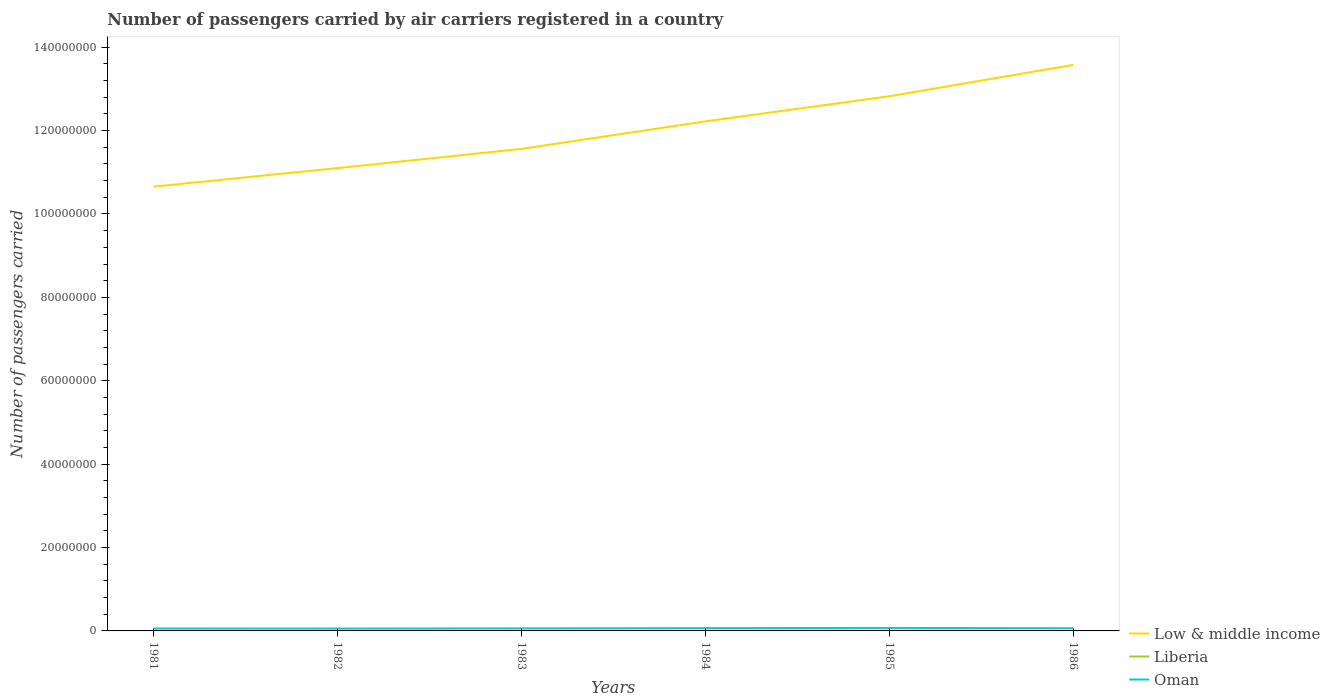Across all years, what is the maximum number of passengers carried by air carriers in Oman?
Provide a succinct answer. 5.70e+05. What is the total number of passengers carried by air carriers in Low & middle income in the graph?
Provide a succinct answer. -2.48e+07. What is the difference between the highest and the second highest number of passengers carried by air carriers in Low & middle income?
Provide a short and direct response. 2.92e+07. What is the difference between the highest and the lowest number of passengers carried by air carriers in Oman?
Your answer should be very brief. 3. How many lines are there?
Provide a succinct answer. 3. How many years are there in the graph?
Your answer should be compact. 6. Are the values on the major ticks of Y-axis written in scientific E-notation?
Provide a short and direct response. No. Where does the legend appear in the graph?
Give a very brief answer. Bottom right. How many legend labels are there?
Give a very brief answer. 3. How are the legend labels stacked?
Give a very brief answer. Vertical. What is the title of the graph?
Give a very brief answer. Number of passengers carried by air carriers registered in a country. Does "Uganda" appear as one of the legend labels in the graph?
Ensure brevity in your answer.  No. What is the label or title of the X-axis?
Your response must be concise. Years. What is the label or title of the Y-axis?
Your answer should be compact. Number of passengers carried. What is the Number of passengers carried of Low & middle income in 1981?
Give a very brief answer. 1.07e+08. What is the Number of passengers carried of Liberia in 1981?
Your answer should be very brief. 3.04e+04. What is the Number of passengers carried of Oman in 1981?
Your answer should be compact. 5.78e+05. What is the Number of passengers carried of Low & middle income in 1982?
Give a very brief answer. 1.11e+08. What is the Number of passengers carried in Liberia in 1982?
Provide a succinct answer. 4.09e+04. What is the Number of passengers carried in Oman in 1982?
Offer a terse response. 5.70e+05. What is the Number of passengers carried in Low & middle income in 1983?
Make the answer very short. 1.16e+08. What is the Number of passengers carried of Liberia in 1983?
Your answer should be very brief. 4.40e+04. What is the Number of passengers carried in Oman in 1983?
Make the answer very short. 6.02e+05. What is the Number of passengers carried in Low & middle income in 1984?
Your response must be concise. 1.22e+08. What is the Number of passengers carried in Oman in 1984?
Provide a short and direct response. 6.74e+05. What is the Number of passengers carried of Low & middle income in 1985?
Ensure brevity in your answer.  1.28e+08. What is the Number of passengers carried in Liberia in 1985?
Ensure brevity in your answer.  4.20e+04. What is the Number of passengers carried in Oman in 1985?
Ensure brevity in your answer.  7.18e+05. What is the Number of passengers carried of Low & middle income in 1986?
Your response must be concise. 1.36e+08. What is the Number of passengers carried in Liberia in 1986?
Your response must be concise. 4.20e+04. What is the Number of passengers carried of Oman in 1986?
Your answer should be very brief. 6.47e+05. Across all years, what is the maximum Number of passengers carried of Low & middle income?
Keep it short and to the point. 1.36e+08. Across all years, what is the maximum Number of passengers carried in Oman?
Offer a very short reply. 7.18e+05. Across all years, what is the minimum Number of passengers carried of Low & middle income?
Ensure brevity in your answer.  1.07e+08. Across all years, what is the minimum Number of passengers carried in Liberia?
Provide a succinct answer. 3.04e+04. Across all years, what is the minimum Number of passengers carried in Oman?
Provide a succinct answer. 5.70e+05. What is the total Number of passengers carried of Low & middle income in the graph?
Give a very brief answer. 7.19e+08. What is the total Number of passengers carried of Liberia in the graph?
Offer a very short reply. 2.49e+05. What is the total Number of passengers carried in Oman in the graph?
Ensure brevity in your answer.  3.79e+06. What is the difference between the Number of passengers carried in Low & middle income in 1981 and that in 1982?
Keep it short and to the point. -4.45e+06. What is the difference between the Number of passengers carried of Liberia in 1981 and that in 1982?
Give a very brief answer. -1.05e+04. What is the difference between the Number of passengers carried of Oman in 1981 and that in 1982?
Give a very brief answer. 8000. What is the difference between the Number of passengers carried in Low & middle income in 1981 and that in 1983?
Keep it short and to the point. -9.05e+06. What is the difference between the Number of passengers carried of Liberia in 1981 and that in 1983?
Your response must be concise. -1.36e+04. What is the difference between the Number of passengers carried in Oman in 1981 and that in 1983?
Your answer should be compact. -2.40e+04. What is the difference between the Number of passengers carried in Low & middle income in 1981 and that in 1984?
Your answer should be very brief. -1.57e+07. What is the difference between the Number of passengers carried in Liberia in 1981 and that in 1984?
Give a very brief answer. -1.96e+04. What is the difference between the Number of passengers carried of Oman in 1981 and that in 1984?
Make the answer very short. -9.64e+04. What is the difference between the Number of passengers carried of Low & middle income in 1981 and that in 1985?
Offer a terse response. -2.17e+07. What is the difference between the Number of passengers carried in Liberia in 1981 and that in 1985?
Give a very brief answer. -1.16e+04. What is the difference between the Number of passengers carried of Oman in 1981 and that in 1985?
Offer a very short reply. -1.40e+05. What is the difference between the Number of passengers carried of Low & middle income in 1981 and that in 1986?
Your answer should be compact. -2.92e+07. What is the difference between the Number of passengers carried of Liberia in 1981 and that in 1986?
Your answer should be very brief. -1.16e+04. What is the difference between the Number of passengers carried in Oman in 1981 and that in 1986?
Offer a very short reply. -6.96e+04. What is the difference between the Number of passengers carried in Low & middle income in 1982 and that in 1983?
Your response must be concise. -4.61e+06. What is the difference between the Number of passengers carried of Liberia in 1982 and that in 1983?
Your answer should be compact. -3100. What is the difference between the Number of passengers carried in Oman in 1982 and that in 1983?
Give a very brief answer. -3.20e+04. What is the difference between the Number of passengers carried in Low & middle income in 1982 and that in 1984?
Give a very brief answer. -1.12e+07. What is the difference between the Number of passengers carried of Liberia in 1982 and that in 1984?
Your response must be concise. -9100. What is the difference between the Number of passengers carried in Oman in 1982 and that in 1984?
Make the answer very short. -1.04e+05. What is the difference between the Number of passengers carried in Low & middle income in 1982 and that in 1985?
Offer a very short reply. -1.72e+07. What is the difference between the Number of passengers carried in Liberia in 1982 and that in 1985?
Provide a short and direct response. -1100. What is the difference between the Number of passengers carried of Oman in 1982 and that in 1985?
Provide a succinct answer. -1.48e+05. What is the difference between the Number of passengers carried of Low & middle income in 1982 and that in 1986?
Make the answer very short. -2.48e+07. What is the difference between the Number of passengers carried in Liberia in 1982 and that in 1986?
Ensure brevity in your answer.  -1100. What is the difference between the Number of passengers carried in Oman in 1982 and that in 1986?
Provide a short and direct response. -7.76e+04. What is the difference between the Number of passengers carried of Low & middle income in 1983 and that in 1984?
Your answer should be compact. -6.60e+06. What is the difference between the Number of passengers carried of Liberia in 1983 and that in 1984?
Make the answer very short. -6000. What is the difference between the Number of passengers carried of Oman in 1983 and that in 1984?
Provide a succinct answer. -7.24e+04. What is the difference between the Number of passengers carried in Low & middle income in 1983 and that in 1985?
Keep it short and to the point. -1.26e+07. What is the difference between the Number of passengers carried of Liberia in 1983 and that in 1985?
Your answer should be very brief. 2000. What is the difference between the Number of passengers carried in Oman in 1983 and that in 1985?
Your answer should be compact. -1.16e+05. What is the difference between the Number of passengers carried of Low & middle income in 1983 and that in 1986?
Offer a terse response. -2.02e+07. What is the difference between the Number of passengers carried in Liberia in 1983 and that in 1986?
Keep it short and to the point. 2000. What is the difference between the Number of passengers carried of Oman in 1983 and that in 1986?
Ensure brevity in your answer.  -4.56e+04. What is the difference between the Number of passengers carried of Low & middle income in 1984 and that in 1985?
Give a very brief answer. -6.03e+06. What is the difference between the Number of passengers carried of Liberia in 1984 and that in 1985?
Ensure brevity in your answer.  8000. What is the difference between the Number of passengers carried of Oman in 1984 and that in 1985?
Ensure brevity in your answer.  -4.33e+04. What is the difference between the Number of passengers carried in Low & middle income in 1984 and that in 1986?
Keep it short and to the point. -1.35e+07. What is the difference between the Number of passengers carried in Liberia in 1984 and that in 1986?
Your response must be concise. 8000. What is the difference between the Number of passengers carried in Oman in 1984 and that in 1986?
Provide a succinct answer. 2.68e+04. What is the difference between the Number of passengers carried of Low & middle income in 1985 and that in 1986?
Your answer should be very brief. -7.52e+06. What is the difference between the Number of passengers carried in Oman in 1985 and that in 1986?
Offer a terse response. 7.01e+04. What is the difference between the Number of passengers carried in Low & middle income in 1981 and the Number of passengers carried in Liberia in 1982?
Offer a terse response. 1.07e+08. What is the difference between the Number of passengers carried of Low & middle income in 1981 and the Number of passengers carried of Oman in 1982?
Provide a short and direct response. 1.06e+08. What is the difference between the Number of passengers carried in Liberia in 1981 and the Number of passengers carried in Oman in 1982?
Your answer should be compact. -5.39e+05. What is the difference between the Number of passengers carried of Low & middle income in 1981 and the Number of passengers carried of Liberia in 1983?
Give a very brief answer. 1.07e+08. What is the difference between the Number of passengers carried of Low & middle income in 1981 and the Number of passengers carried of Oman in 1983?
Keep it short and to the point. 1.06e+08. What is the difference between the Number of passengers carried in Liberia in 1981 and the Number of passengers carried in Oman in 1983?
Your answer should be compact. -5.71e+05. What is the difference between the Number of passengers carried in Low & middle income in 1981 and the Number of passengers carried in Liberia in 1984?
Offer a terse response. 1.07e+08. What is the difference between the Number of passengers carried in Low & middle income in 1981 and the Number of passengers carried in Oman in 1984?
Offer a very short reply. 1.06e+08. What is the difference between the Number of passengers carried in Liberia in 1981 and the Number of passengers carried in Oman in 1984?
Offer a terse response. -6.44e+05. What is the difference between the Number of passengers carried in Low & middle income in 1981 and the Number of passengers carried in Liberia in 1985?
Make the answer very short. 1.07e+08. What is the difference between the Number of passengers carried in Low & middle income in 1981 and the Number of passengers carried in Oman in 1985?
Your answer should be compact. 1.06e+08. What is the difference between the Number of passengers carried of Liberia in 1981 and the Number of passengers carried of Oman in 1985?
Give a very brief answer. -6.87e+05. What is the difference between the Number of passengers carried in Low & middle income in 1981 and the Number of passengers carried in Liberia in 1986?
Offer a very short reply. 1.07e+08. What is the difference between the Number of passengers carried in Low & middle income in 1981 and the Number of passengers carried in Oman in 1986?
Provide a short and direct response. 1.06e+08. What is the difference between the Number of passengers carried of Liberia in 1981 and the Number of passengers carried of Oman in 1986?
Provide a succinct answer. -6.17e+05. What is the difference between the Number of passengers carried in Low & middle income in 1982 and the Number of passengers carried in Liberia in 1983?
Ensure brevity in your answer.  1.11e+08. What is the difference between the Number of passengers carried in Low & middle income in 1982 and the Number of passengers carried in Oman in 1983?
Offer a very short reply. 1.10e+08. What is the difference between the Number of passengers carried of Liberia in 1982 and the Number of passengers carried of Oman in 1983?
Give a very brief answer. -5.61e+05. What is the difference between the Number of passengers carried of Low & middle income in 1982 and the Number of passengers carried of Liberia in 1984?
Keep it short and to the point. 1.11e+08. What is the difference between the Number of passengers carried in Low & middle income in 1982 and the Number of passengers carried in Oman in 1984?
Provide a short and direct response. 1.10e+08. What is the difference between the Number of passengers carried of Liberia in 1982 and the Number of passengers carried of Oman in 1984?
Ensure brevity in your answer.  -6.33e+05. What is the difference between the Number of passengers carried in Low & middle income in 1982 and the Number of passengers carried in Liberia in 1985?
Ensure brevity in your answer.  1.11e+08. What is the difference between the Number of passengers carried of Low & middle income in 1982 and the Number of passengers carried of Oman in 1985?
Provide a short and direct response. 1.10e+08. What is the difference between the Number of passengers carried of Liberia in 1982 and the Number of passengers carried of Oman in 1985?
Keep it short and to the point. -6.77e+05. What is the difference between the Number of passengers carried of Low & middle income in 1982 and the Number of passengers carried of Liberia in 1986?
Provide a short and direct response. 1.11e+08. What is the difference between the Number of passengers carried in Low & middle income in 1982 and the Number of passengers carried in Oman in 1986?
Keep it short and to the point. 1.10e+08. What is the difference between the Number of passengers carried in Liberia in 1982 and the Number of passengers carried in Oman in 1986?
Offer a terse response. -6.06e+05. What is the difference between the Number of passengers carried in Low & middle income in 1983 and the Number of passengers carried in Liberia in 1984?
Make the answer very short. 1.16e+08. What is the difference between the Number of passengers carried in Low & middle income in 1983 and the Number of passengers carried in Oman in 1984?
Give a very brief answer. 1.15e+08. What is the difference between the Number of passengers carried in Liberia in 1983 and the Number of passengers carried in Oman in 1984?
Make the answer very short. -6.30e+05. What is the difference between the Number of passengers carried in Low & middle income in 1983 and the Number of passengers carried in Liberia in 1985?
Provide a short and direct response. 1.16e+08. What is the difference between the Number of passengers carried of Low & middle income in 1983 and the Number of passengers carried of Oman in 1985?
Make the answer very short. 1.15e+08. What is the difference between the Number of passengers carried of Liberia in 1983 and the Number of passengers carried of Oman in 1985?
Provide a short and direct response. -6.74e+05. What is the difference between the Number of passengers carried in Low & middle income in 1983 and the Number of passengers carried in Liberia in 1986?
Provide a short and direct response. 1.16e+08. What is the difference between the Number of passengers carried of Low & middle income in 1983 and the Number of passengers carried of Oman in 1986?
Offer a terse response. 1.15e+08. What is the difference between the Number of passengers carried of Liberia in 1983 and the Number of passengers carried of Oman in 1986?
Your response must be concise. -6.03e+05. What is the difference between the Number of passengers carried in Low & middle income in 1984 and the Number of passengers carried in Liberia in 1985?
Provide a succinct answer. 1.22e+08. What is the difference between the Number of passengers carried in Low & middle income in 1984 and the Number of passengers carried in Oman in 1985?
Provide a succinct answer. 1.21e+08. What is the difference between the Number of passengers carried in Liberia in 1984 and the Number of passengers carried in Oman in 1985?
Your response must be concise. -6.68e+05. What is the difference between the Number of passengers carried of Low & middle income in 1984 and the Number of passengers carried of Liberia in 1986?
Ensure brevity in your answer.  1.22e+08. What is the difference between the Number of passengers carried of Low & middle income in 1984 and the Number of passengers carried of Oman in 1986?
Your answer should be compact. 1.22e+08. What is the difference between the Number of passengers carried of Liberia in 1984 and the Number of passengers carried of Oman in 1986?
Offer a terse response. -5.97e+05. What is the difference between the Number of passengers carried of Low & middle income in 1985 and the Number of passengers carried of Liberia in 1986?
Provide a short and direct response. 1.28e+08. What is the difference between the Number of passengers carried of Low & middle income in 1985 and the Number of passengers carried of Oman in 1986?
Ensure brevity in your answer.  1.28e+08. What is the difference between the Number of passengers carried of Liberia in 1985 and the Number of passengers carried of Oman in 1986?
Your answer should be compact. -6.05e+05. What is the average Number of passengers carried of Low & middle income per year?
Offer a terse response. 1.20e+08. What is the average Number of passengers carried of Liberia per year?
Provide a short and direct response. 4.16e+04. What is the average Number of passengers carried in Oman per year?
Your answer should be compact. 6.31e+05. In the year 1981, what is the difference between the Number of passengers carried in Low & middle income and Number of passengers carried in Liberia?
Provide a succinct answer. 1.07e+08. In the year 1981, what is the difference between the Number of passengers carried in Low & middle income and Number of passengers carried in Oman?
Your response must be concise. 1.06e+08. In the year 1981, what is the difference between the Number of passengers carried of Liberia and Number of passengers carried of Oman?
Offer a terse response. -5.47e+05. In the year 1982, what is the difference between the Number of passengers carried of Low & middle income and Number of passengers carried of Liberia?
Keep it short and to the point. 1.11e+08. In the year 1982, what is the difference between the Number of passengers carried in Low & middle income and Number of passengers carried in Oman?
Your response must be concise. 1.10e+08. In the year 1982, what is the difference between the Number of passengers carried in Liberia and Number of passengers carried in Oman?
Make the answer very short. -5.29e+05. In the year 1983, what is the difference between the Number of passengers carried in Low & middle income and Number of passengers carried in Liberia?
Make the answer very short. 1.16e+08. In the year 1983, what is the difference between the Number of passengers carried in Low & middle income and Number of passengers carried in Oman?
Your answer should be compact. 1.15e+08. In the year 1983, what is the difference between the Number of passengers carried of Liberia and Number of passengers carried of Oman?
Give a very brief answer. -5.58e+05. In the year 1984, what is the difference between the Number of passengers carried in Low & middle income and Number of passengers carried in Liberia?
Keep it short and to the point. 1.22e+08. In the year 1984, what is the difference between the Number of passengers carried in Low & middle income and Number of passengers carried in Oman?
Provide a succinct answer. 1.22e+08. In the year 1984, what is the difference between the Number of passengers carried in Liberia and Number of passengers carried in Oman?
Offer a terse response. -6.24e+05. In the year 1985, what is the difference between the Number of passengers carried of Low & middle income and Number of passengers carried of Liberia?
Offer a very short reply. 1.28e+08. In the year 1985, what is the difference between the Number of passengers carried in Low & middle income and Number of passengers carried in Oman?
Offer a terse response. 1.28e+08. In the year 1985, what is the difference between the Number of passengers carried in Liberia and Number of passengers carried in Oman?
Keep it short and to the point. -6.76e+05. In the year 1986, what is the difference between the Number of passengers carried in Low & middle income and Number of passengers carried in Liberia?
Give a very brief answer. 1.36e+08. In the year 1986, what is the difference between the Number of passengers carried in Low & middle income and Number of passengers carried in Oman?
Give a very brief answer. 1.35e+08. In the year 1986, what is the difference between the Number of passengers carried in Liberia and Number of passengers carried in Oman?
Provide a succinct answer. -6.05e+05. What is the ratio of the Number of passengers carried of Low & middle income in 1981 to that in 1982?
Your answer should be compact. 0.96. What is the ratio of the Number of passengers carried of Liberia in 1981 to that in 1982?
Provide a short and direct response. 0.74. What is the ratio of the Number of passengers carried in Oman in 1981 to that in 1982?
Provide a short and direct response. 1.01. What is the ratio of the Number of passengers carried in Low & middle income in 1981 to that in 1983?
Give a very brief answer. 0.92. What is the ratio of the Number of passengers carried of Liberia in 1981 to that in 1983?
Your answer should be compact. 0.69. What is the ratio of the Number of passengers carried of Oman in 1981 to that in 1983?
Make the answer very short. 0.96. What is the ratio of the Number of passengers carried of Low & middle income in 1981 to that in 1984?
Your answer should be very brief. 0.87. What is the ratio of the Number of passengers carried of Liberia in 1981 to that in 1984?
Your response must be concise. 0.61. What is the ratio of the Number of passengers carried in Oman in 1981 to that in 1984?
Provide a short and direct response. 0.86. What is the ratio of the Number of passengers carried of Low & middle income in 1981 to that in 1985?
Provide a succinct answer. 0.83. What is the ratio of the Number of passengers carried of Liberia in 1981 to that in 1985?
Your answer should be very brief. 0.72. What is the ratio of the Number of passengers carried of Oman in 1981 to that in 1985?
Your answer should be compact. 0.81. What is the ratio of the Number of passengers carried of Low & middle income in 1981 to that in 1986?
Offer a terse response. 0.78. What is the ratio of the Number of passengers carried of Liberia in 1981 to that in 1986?
Your answer should be very brief. 0.72. What is the ratio of the Number of passengers carried in Oman in 1981 to that in 1986?
Your answer should be very brief. 0.89. What is the ratio of the Number of passengers carried of Low & middle income in 1982 to that in 1983?
Ensure brevity in your answer.  0.96. What is the ratio of the Number of passengers carried of Liberia in 1982 to that in 1983?
Your answer should be very brief. 0.93. What is the ratio of the Number of passengers carried in Oman in 1982 to that in 1983?
Your response must be concise. 0.95. What is the ratio of the Number of passengers carried in Low & middle income in 1982 to that in 1984?
Make the answer very short. 0.91. What is the ratio of the Number of passengers carried of Liberia in 1982 to that in 1984?
Your response must be concise. 0.82. What is the ratio of the Number of passengers carried of Oman in 1982 to that in 1984?
Make the answer very short. 0.85. What is the ratio of the Number of passengers carried of Low & middle income in 1982 to that in 1985?
Offer a terse response. 0.87. What is the ratio of the Number of passengers carried in Liberia in 1982 to that in 1985?
Your answer should be compact. 0.97. What is the ratio of the Number of passengers carried of Oman in 1982 to that in 1985?
Your response must be concise. 0.79. What is the ratio of the Number of passengers carried in Low & middle income in 1982 to that in 1986?
Your response must be concise. 0.82. What is the ratio of the Number of passengers carried of Liberia in 1982 to that in 1986?
Your response must be concise. 0.97. What is the ratio of the Number of passengers carried in Oman in 1982 to that in 1986?
Make the answer very short. 0.88. What is the ratio of the Number of passengers carried of Low & middle income in 1983 to that in 1984?
Ensure brevity in your answer.  0.95. What is the ratio of the Number of passengers carried in Liberia in 1983 to that in 1984?
Offer a terse response. 0.88. What is the ratio of the Number of passengers carried of Oman in 1983 to that in 1984?
Your response must be concise. 0.89. What is the ratio of the Number of passengers carried of Low & middle income in 1983 to that in 1985?
Offer a very short reply. 0.9. What is the ratio of the Number of passengers carried of Liberia in 1983 to that in 1985?
Offer a very short reply. 1.05. What is the ratio of the Number of passengers carried in Oman in 1983 to that in 1985?
Offer a terse response. 0.84. What is the ratio of the Number of passengers carried in Low & middle income in 1983 to that in 1986?
Offer a terse response. 0.85. What is the ratio of the Number of passengers carried in Liberia in 1983 to that in 1986?
Offer a terse response. 1.05. What is the ratio of the Number of passengers carried in Oman in 1983 to that in 1986?
Keep it short and to the point. 0.93. What is the ratio of the Number of passengers carried in Low & middle income in 1984 to that in 1985?
Offer a terse response. 0.95. What is the ratio of the Number of passengers carried of Liberia in 1984 to that in 1985?
Offer a very short reply. 1.19. What is the ratio of the Number of passengers carried of Oman in 1984 to that in 1985?
Provide a short and direct response. 0.94. What is the ratio of the Number of passengers carried of Low & middle income in 1984 to that in 1986?
Your answer should be very brief. 0.9. What is the ratio of the Number of passengers carried in Liberia in 1984 to that in 1986?
Give a very brief answer. 1.19. What is the ratio of the Number of passengers carried of Oman in 1984 to that in 1986?
Your response must be concise. 1.04. What is the ratio of the Number of passengers carried of Low & middle income in 1985 to that in 1986?
Your response must be concise. 0.94. What is the ratio of the Number of passengers carried of Oman in 1985 to that in 1986?
Provide a succinct answer. 1.11. What is the difference between the highest and the second highest Number of passengers carried in Low & middle income?
Your answer should be very brief. 7.52e+06. What is the difference between the highest and the second highest Number of passengers carried of Liberia?
Ensure brevity in your answer.  6000. What is the difference between the highest and the second highest Number of passengers carried of Oman?
Give a very brief answer. 4.33e+04. What is the difference between the highest and the lowest Number of passengers carried of Low & middle income?
Offer a terse response. 2.92e+07. What is the difference between the highest and the lowest Number of passengers carried in Liberia?
Your answer should be very brief. 1.96e+04. What is the difference between the highest and the lowest Number of passengers carried in Oman?
Your answer should be compact. 1.48e+05. 